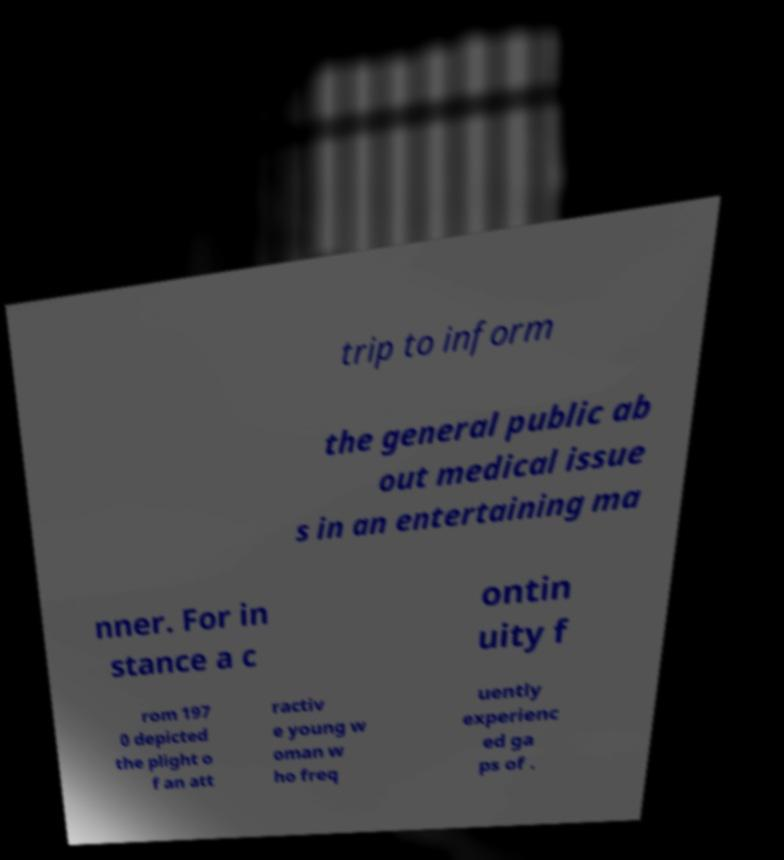For documentation purposes, I need the text within this image transcribed. Could you provide that? trip to inform the general public ab out medical issue s in an entertaining ma nner. For in stance a c ontin uity f rom 197 0 depicted the plight o f an att ractiv e young w oman w ho freq uently experienc ed ga ps of . 